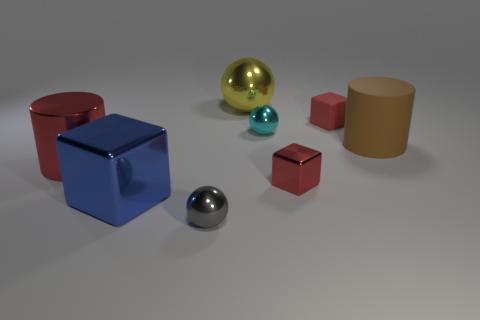How do the different textures in the image interact with the light? The textures in the image play a crucial role in interacting with the light source, creating varying effects. The shiny textures, seen on the spheres and the large blue cube, reflect the light, producing bright highlights and clear reflections of the environment. The matte surfaces, like the red cubes and the large brown cylinder, diffuse the light, resulting in soft, even lighting with no reflection. These differences in texture create a rich diversity of optical effects and help to define the shapes of the objects more distinctly. 